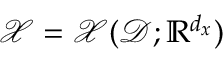<formula> <loc_0><loc_0><loc_500><loc_500>\mathcal { X } = \mathcal { X } ( \mathcal { D } ; \mathbb { R } ^ { d _ { x } } )</formula> 